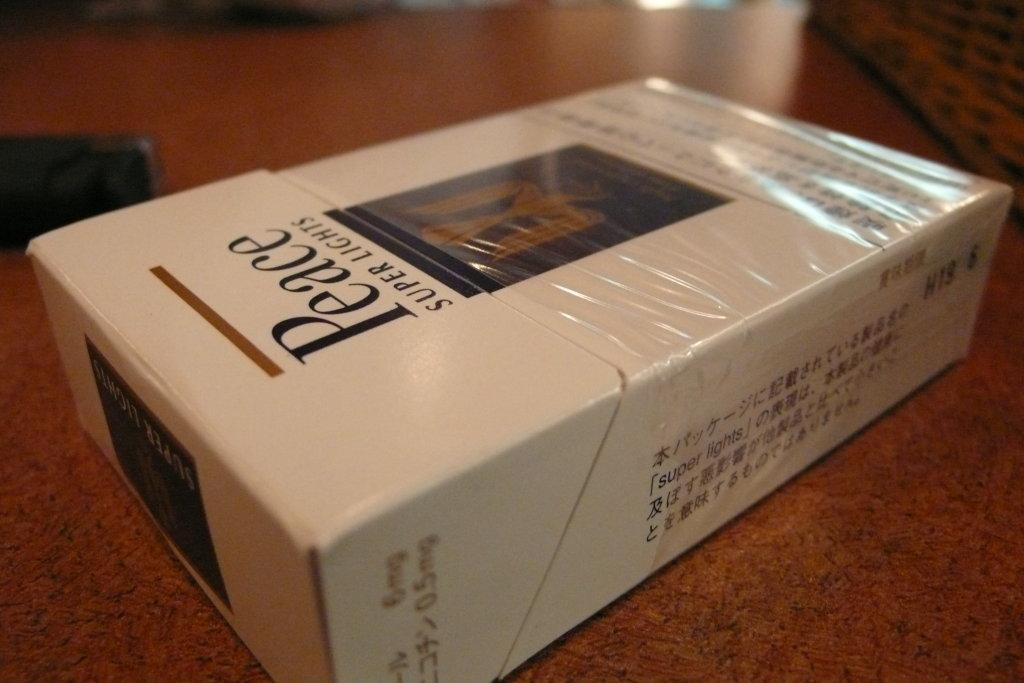<image>
Present a compact description of the photo's key features. A box of Peace super lights style cigarettes. 